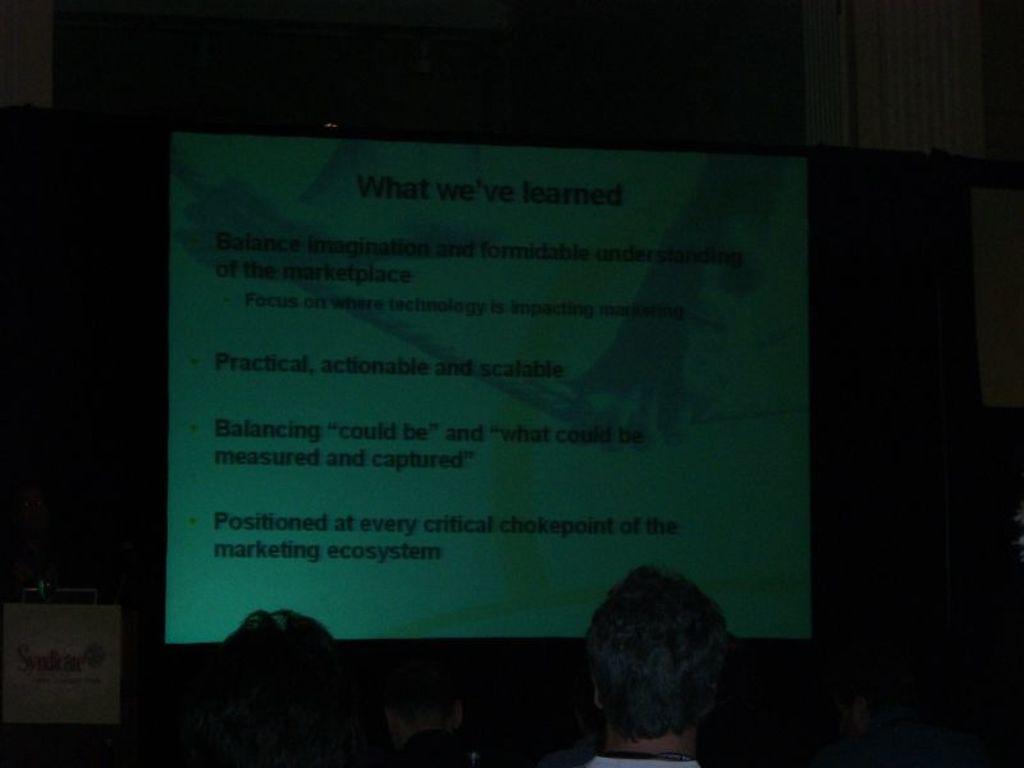Could you give a brief overview of what you see in this image? In the center of the image there is a projector screen. At the bottom of the image there are two persons. In the background of the image there is wall. 